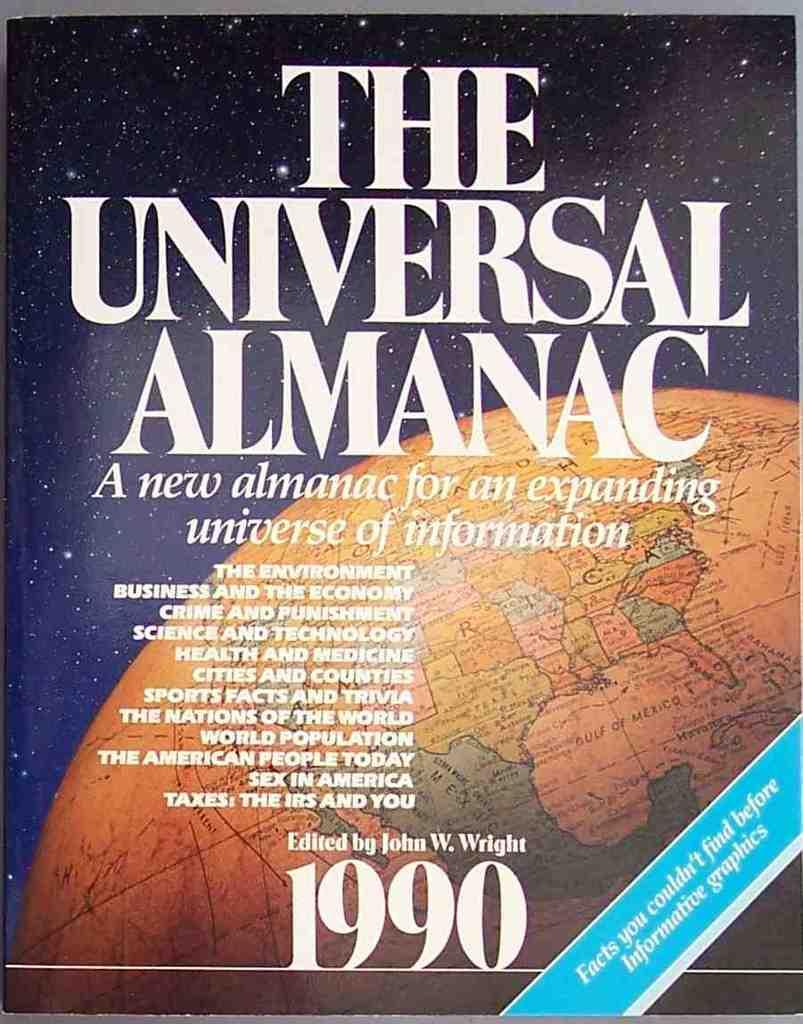<image>
Render a clear and concise summary of the photo. The cover of The Universal Almanac from 1990. 